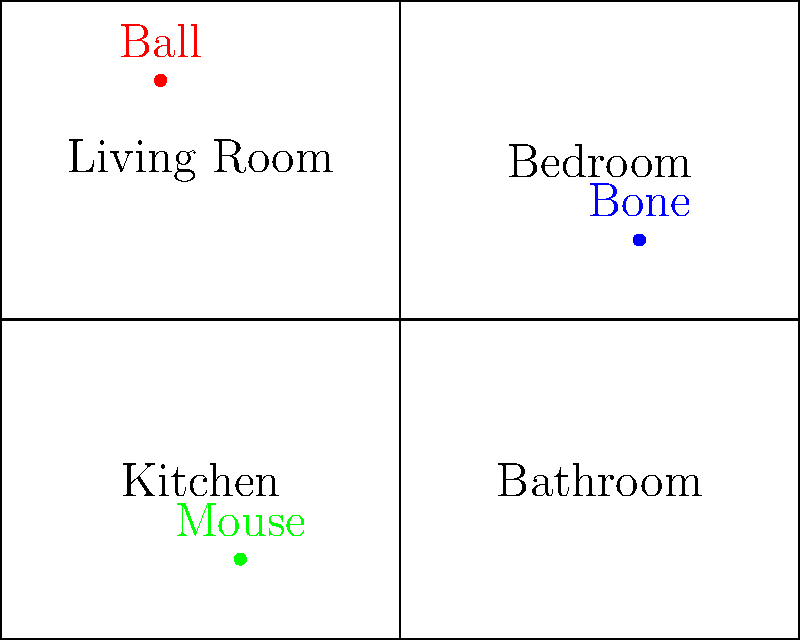Look at the floor plan of your house. Each room is labeled, and your pet's toys are shown as colored dots. The ball is in the Living Room at coordinates (20, 70), the bone is in the Bedroom at (80, 50), and the mouse toy is in the Kitchen at (30, 10). If you want to find your pet's favorite toy, which is the bone, what are its coordinates? Let's follow these steps to find the coordinates of the bone:

1. First, we need to identify which toy is the bone. In the floor plan, we can see that the bone is labeled in blue.

2. Now, we need to locate the bone on the coordinate system. The bone is in the Bedroom, which is the upper-right room of the house.

3. To find the exact coordinates, we need to look at where the blue dot is positioned on the x and y axes.

4. On the x-axis, we can see that the blue dot is at 80.

5. On the y-axis, we can see that the blue dot is at 50.

6. Therefore, the coordinates of the bone are (80, 50).

Remember, coordinates are always written as (x, y), where x is the horizontal position and y is the vertical position.
Answer: (80, 50) 